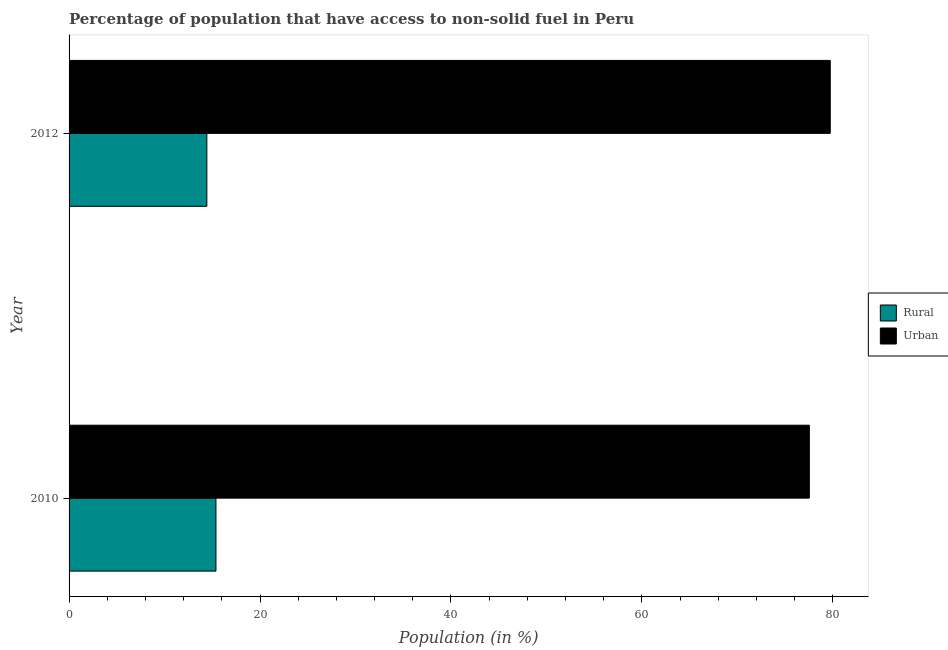How many different coloured bars are there?
Provide a short and direct response. 2. How many groups of bars are there?
Your answer should be compact. 2. What is the label of the 1st group of bars from the top?
Keep it short and to the point. 2012. What is the urban population in 2012?
Provide a succinct answer. 79.73. Across all years, what is the maximum urban population?
Make the answer very short. 79.73. Across all years, what is the minimum rural population?
Provide a succinct answer. 14.43. What is the total rural population in the graph?
Your answer should be very brief. 29.82. What is the difference between the rural population in 2010 and that in 2012?
Provide a succinct answer. 0.95. What is the difference between the rural population in 2010 and the urban population in 2012?
Provide a succinct answer. -64.34. What is the average rural population per year?
Give a very brief answer. 14.91. In the year 2010, what is the difference between the rural population and urban population?
Keep it short and to the point. -62.15. What is the ratio of the rural population in 2010 to that in 2012?
Your response must be concise. 1.07. Is the urban population in 2010 less than that in 2012?
Provide a succinct answer. Yes. Is the difference between the rural population in 2010 and 2012 greater than the difference between the urban population in 2010 and 2012?
Your answer should be very brief. Yes. In how many years, is the urban population greater than the average urban population taken over all years?
Offer a very short reply. 1. What does the 1st bar from the top in 2010 represents?
Ensure brevity in your answer.  Urban. What does the 2nd bar from the bottom in 2010 represents?
Make the answer very short. Urban. How many years are there in the graph?
Make the answer very short. 2. What is the difference between two consecutive major ticks on the X-axis?
Your answer should be very brief. 20. Does the graph contain any zero values?
Provide a short and direct response. No. Where does the legend appear in the graph?
Your answer should be compact. Center right. How many legend labels are there?
Ensure brevity in your answer.  2. What is the title of the graph?
Make the answer very short. Percentage of population that have access to non-solid fuel in Peru. What is the label or title of the X-axis?
Ensure brevity in your answer.  Population (in %). What is the label or title of the Y-axis?
Your response must be concise. Year. What is the Population (in %) in Rural in 2010?
Your response must be concise. 15.39. What is the Population (in %) of Urban in 2010?
Make the answer very short. 77.54. What is the Population (in %) in Rural in 2012?
Keep it short and to the point. 14.43. What is the Population (in %) of Urban in 2012?
Provide a short and direct response. 79.73. Across all years, what is the maximum Population (in %) in Rural?
Your answer should be compact. 15.39. Across all years, what is the maximum Population (in %) in Urban?
Give a very brief answer. 79.73. Across all years, what is the minimum Population (in %) of Rural?
Offer a terse response. 14.43. Across all years, what is the minimum Population (in %) in Urban?
Provide a short and direct response. 77.54. What is the total Population (in %) of Rural in the graph?
Provide a short and direct response. 29.82. What is the total Population (in %) in Urban in the graph?
Offer a terse response. 157.27. What is the difference between the Population (in %) in Rural in 2010 and that in 2012?
Ensure brevity in your answer.  0.95. What is the difference between the Population (in %) in Urban in 2010 and that in 2012?
Offer a terse response. -2.19. What is the difference between the Population (in %) of Rural in 2010 and the Population (in %) of Urban in 2012?
Ensure brevity in your answer.  -64.34. What is the average Population (in %) in Rural per year?
Your answer should be very brief. 14.91. What is the average Population (in %) of Urban per year?
Provide a short and direct response. 78.63. In the year 2010, what is the difference between the Population (in %) in Rural and Population (in %) in Urban?
Your response must be concise. -62.15. In the year 2012, what is the difference between the Population (in %) of Rural and Population (in %) of Urban?
Your answer should be compact. -65.3. What is the ratio of the Population (in %) of Rural in 2010 to that in 2012?
Provide a short and direct response. 1.07. What is the ratio of the Population (in %) in Urban in 2010 to that in 2012?
Offer a terse response. 0.97. What is the difference between the highest and the second highest Population (in %) in Rural?
Make the answer very short. 0.95. What is the difference between the highest and the second highest Population (in %) of Urban?
Make the answer very short. 2.19. What is the difference between the highest and the lowest Population (in %) in Rural?
Give a very brief answer. 0.95. What is the difference between the highest and the lowest Population (in %) in Urban?
Offer a very short reply. 2.19. 